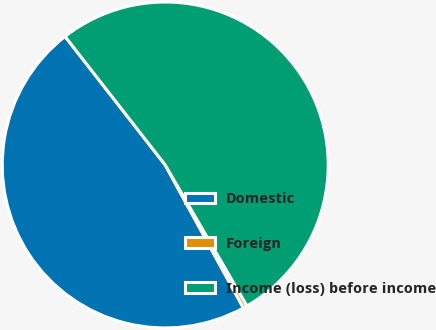Convert chart to OTSL. <chart><loc_0><loc_0><loc_500><loc_500><pie_chart><fcel>Domestic<fcel>Foreign<fcel>Income (loss) before income<nl><fcel>47.43%<fcel>0.4%<fcel>52.17%<nl></chart> 